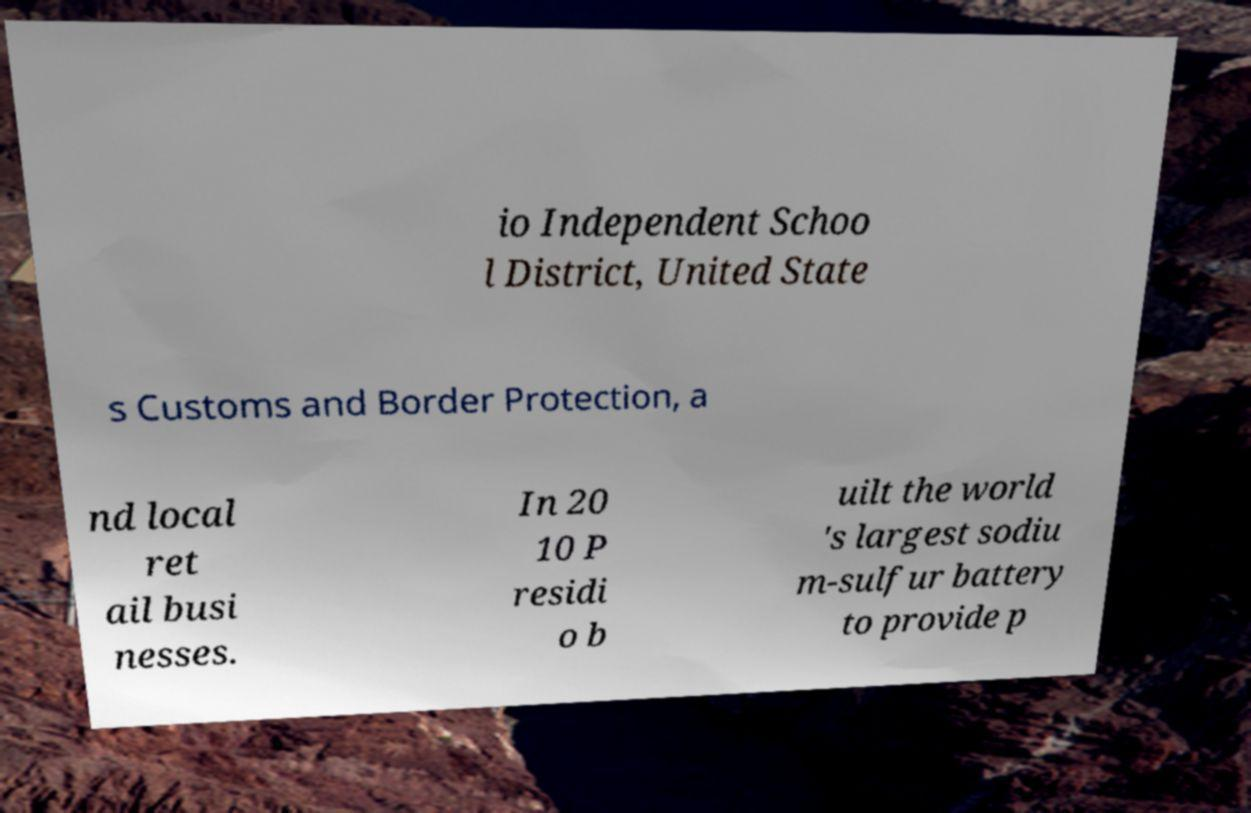Can you read and provide the text displayed in the image?This photo seems to have some interesting text. Can you extract and type it out for me? io Independent Schoo l District, United State s Customs and Border Protection, a nd local ret ail busi nesses. In 20 10 P residi o b uilt the world 's largest sodiu m-sulfur battery to provide p 